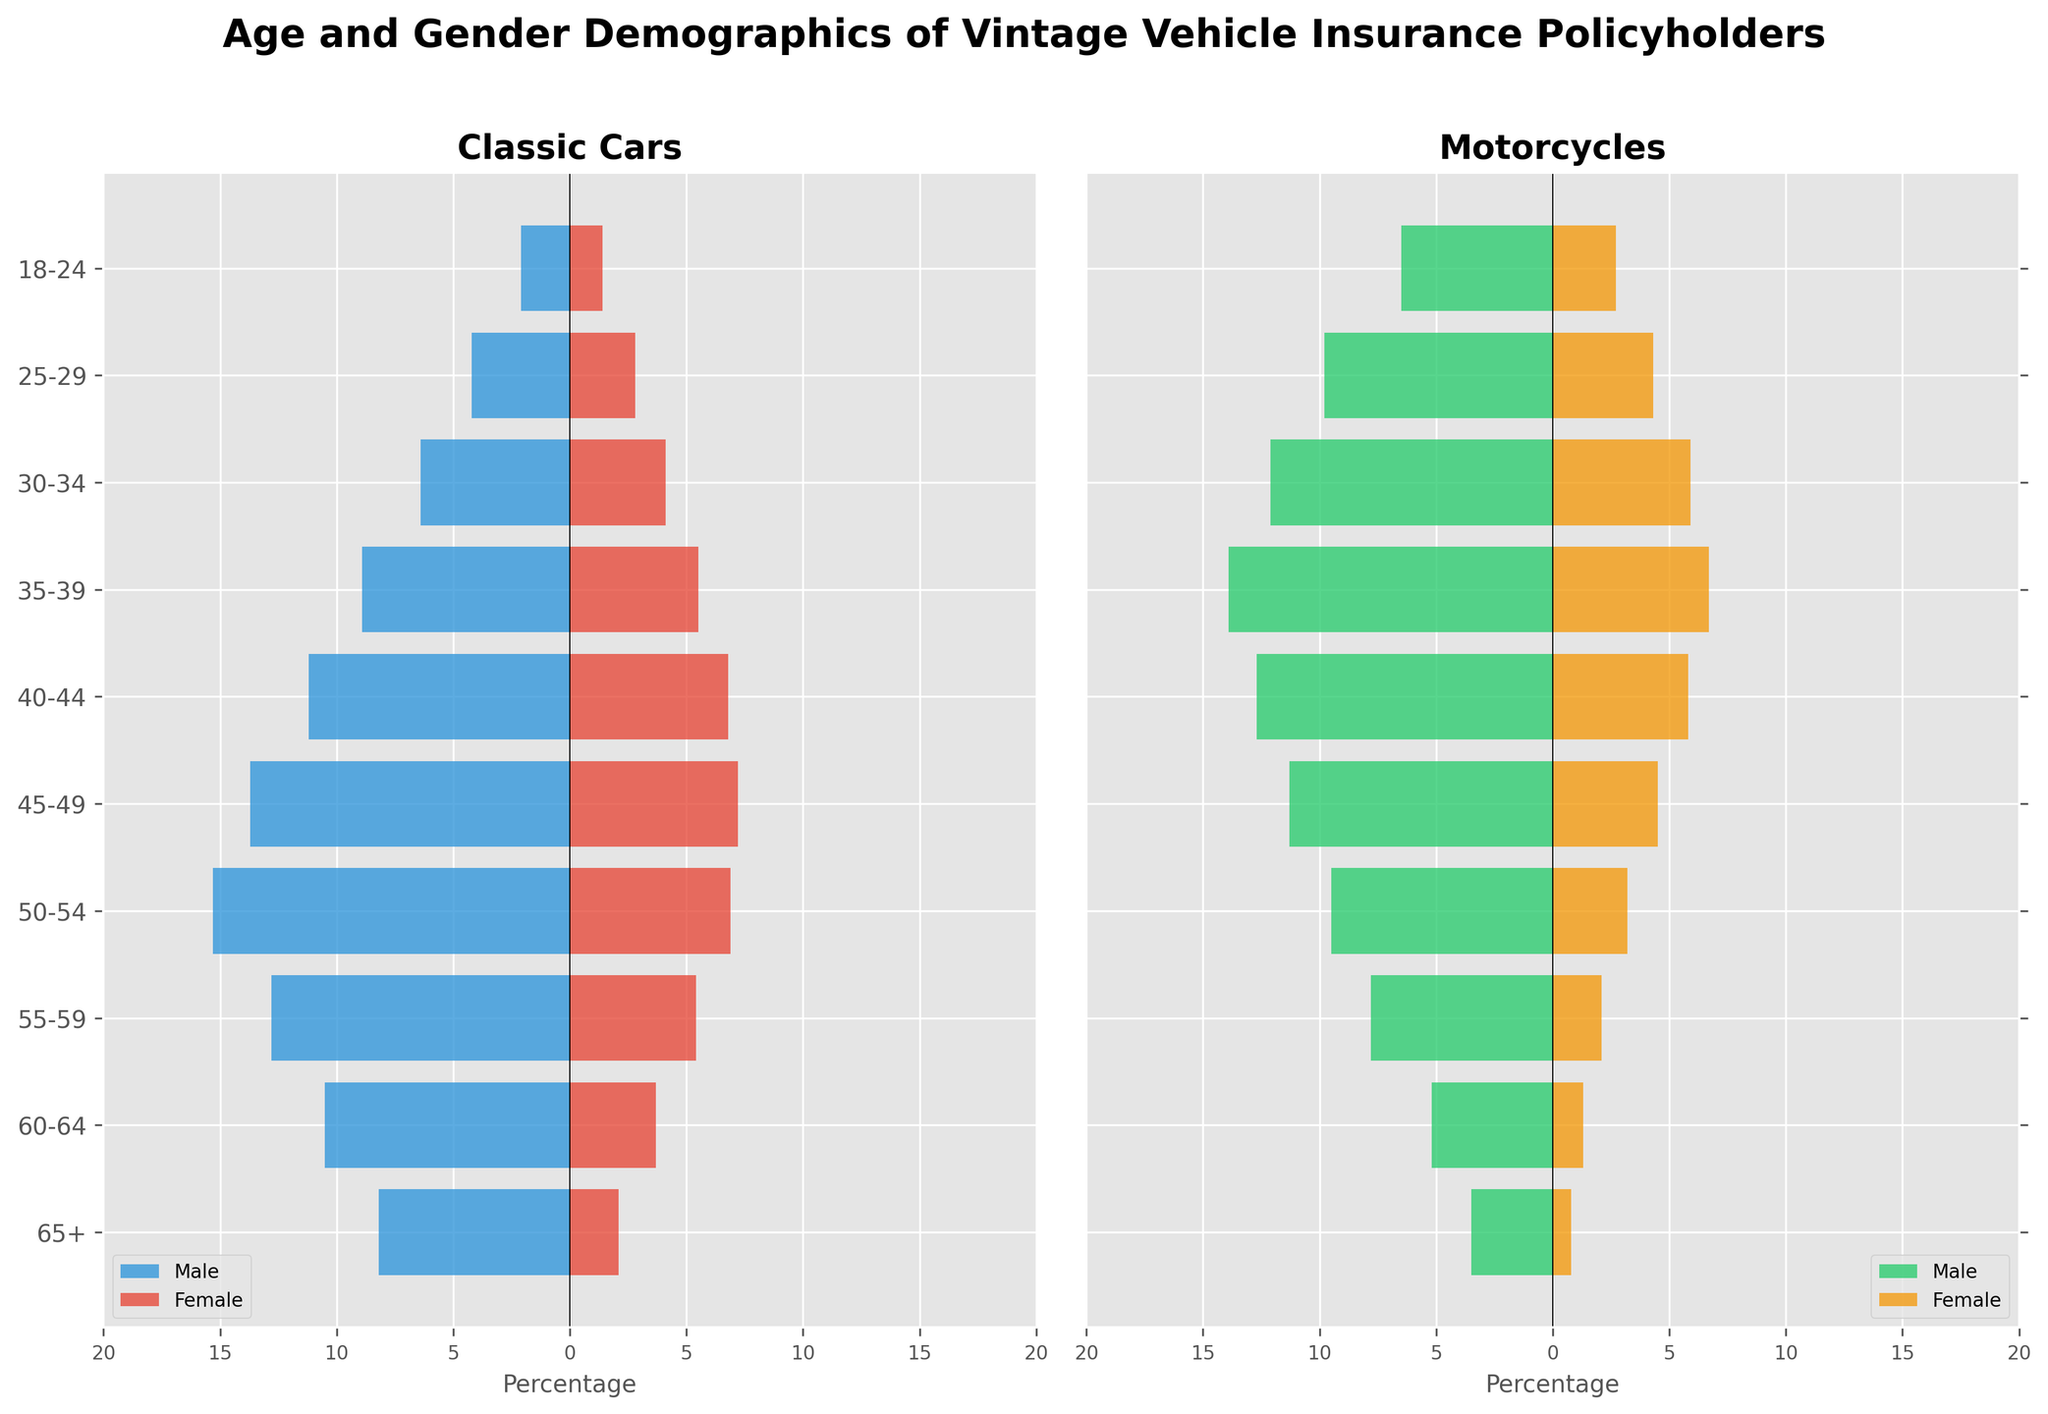What's the title of the figure? The title of the figure is typically found at the top and gives a succinct summary of what the figure is about. In this case, it is "Age and Gender Demographics of Vintage Vehicle Insurance Policyholders."
Answer: Age and Gender Demographics of Vintage Vehicle Insurance Policyholders Which age group has the highest percentage of male classic car policyholders? By examining the left chart labeled "Classic Cars," we see that the age group "50-54" has the longest bar extending to the left for males.
Answer: 50-54 What is the total percentage of female motorcycle policyholders aged 60 and above (60-64 and 65+ combined)? We add the percentage values of female motorcycle policyholders for the age groups "65+" and "60-64": 0.8 + 1.3 = 2.1%.
Answer: 2.1% How do the percentages of male policyholders compare between classic cars and motorcycles for the 35-39 age group? In the age group "35-39," the left chart shows male classic car policyholders at 8.9%, and the right chart shows male motorcycle policyholders at 13.9%. Comparatively, 13.9% is higher than 8.9%.
Answer: Motorcycles have more, 13.9% What is the difference in percentage between male and female classic car policyholders in the 45-49 age group? For the age group "45-49," male policyholders are at 13.7% and female policyholders are at 7.2%. The difference is calculated as 13.7% - 7.2% = 6.5%.
Answer: 6.5% Is there a trend where younger age groups show a higher percentage of motorcycle policyholders compared to classic car policyholders? Upon reviewing both charts, we can observe that younger age groups (especially "18-24" and "25-29") have higher percentages of motorcycle policyholders compared to classic car policyholders. This trend shows that younger age groups prefer motorcycles.
Answer: Yes Which gender has a higher percentage of motorcycle policyholders in the 30-34 age group? Looking at the right chart for motorcycles, we see that in the age group "30-34," male policyholders are at 12.1% and female policyholders are at 5.9%. Males, with 12.1%, have a higher percentage.
Answer: Male What is the combined percentage of all motorcycle policyholders aged 18-24? We sum the percentages for male and female motorcycle policyholders in the age group "18-24": 6.5% (Male) + 2.7% (Female) = 9.2%.
Answer: 9.2% Which age group has the smallest gender gap in classic car policyholders? The smallest gender gap is found by looking at the length of the bars for each gender within each age group. In the age group "25-29," male policyholders are at 4.2% and female policyholders are at 2.8%. The gap is therefore 4.2% - 2.8% = 1.4%, which is the smallest among all age groups.
Answer: 25-29 